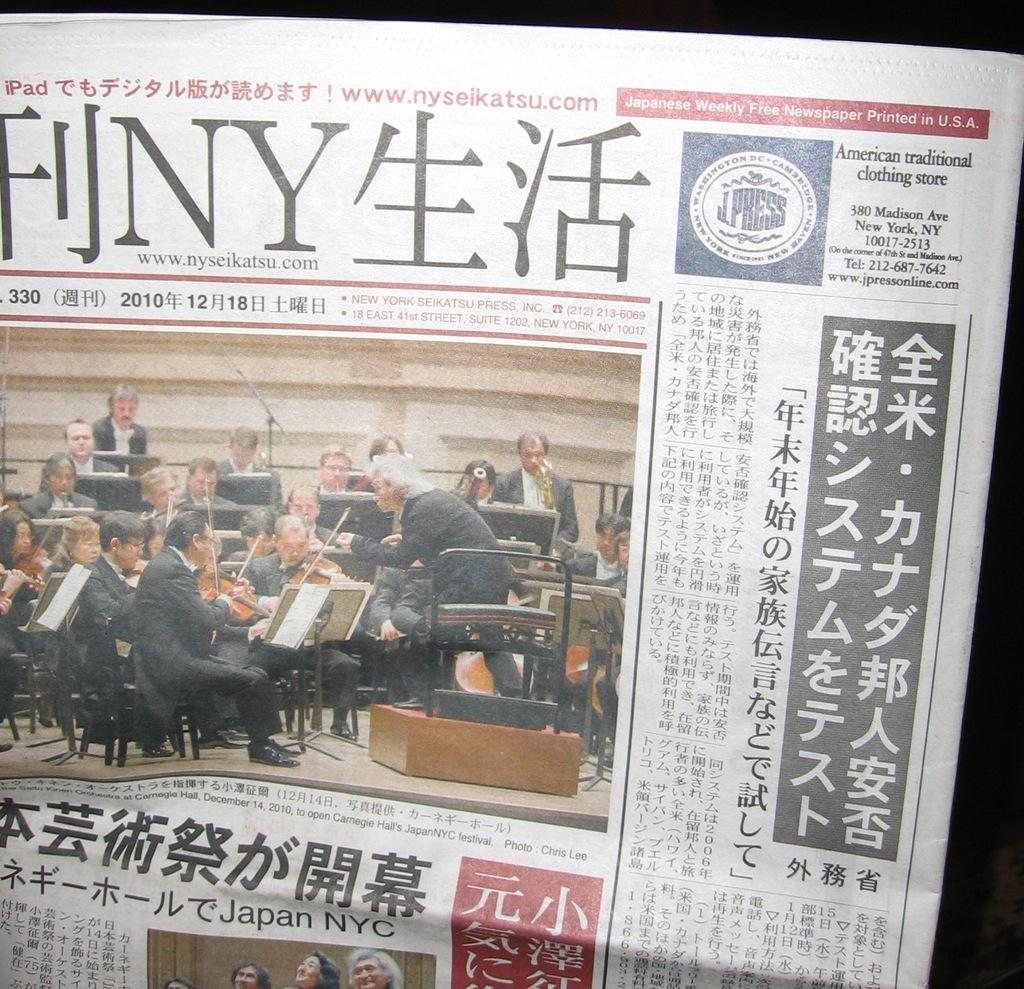Provide a one-sentence caption for the provided image. Japanese Free Newspaper is printed on the upper right corner of the newspaper. 